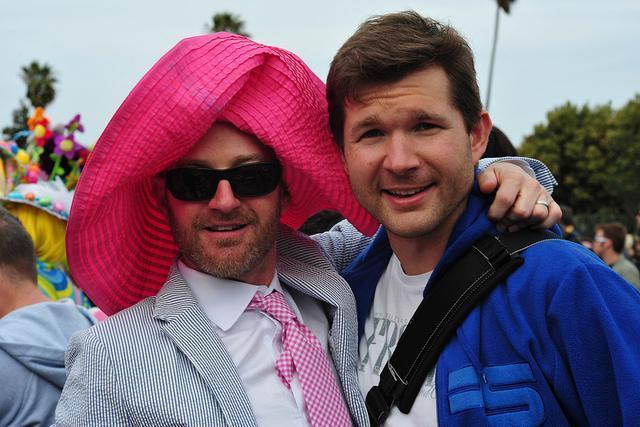How many people can you see?
Give a very brief answer. 4. How many blue bottles is this baby girl looking at?
Give a very brief answer. 0. 